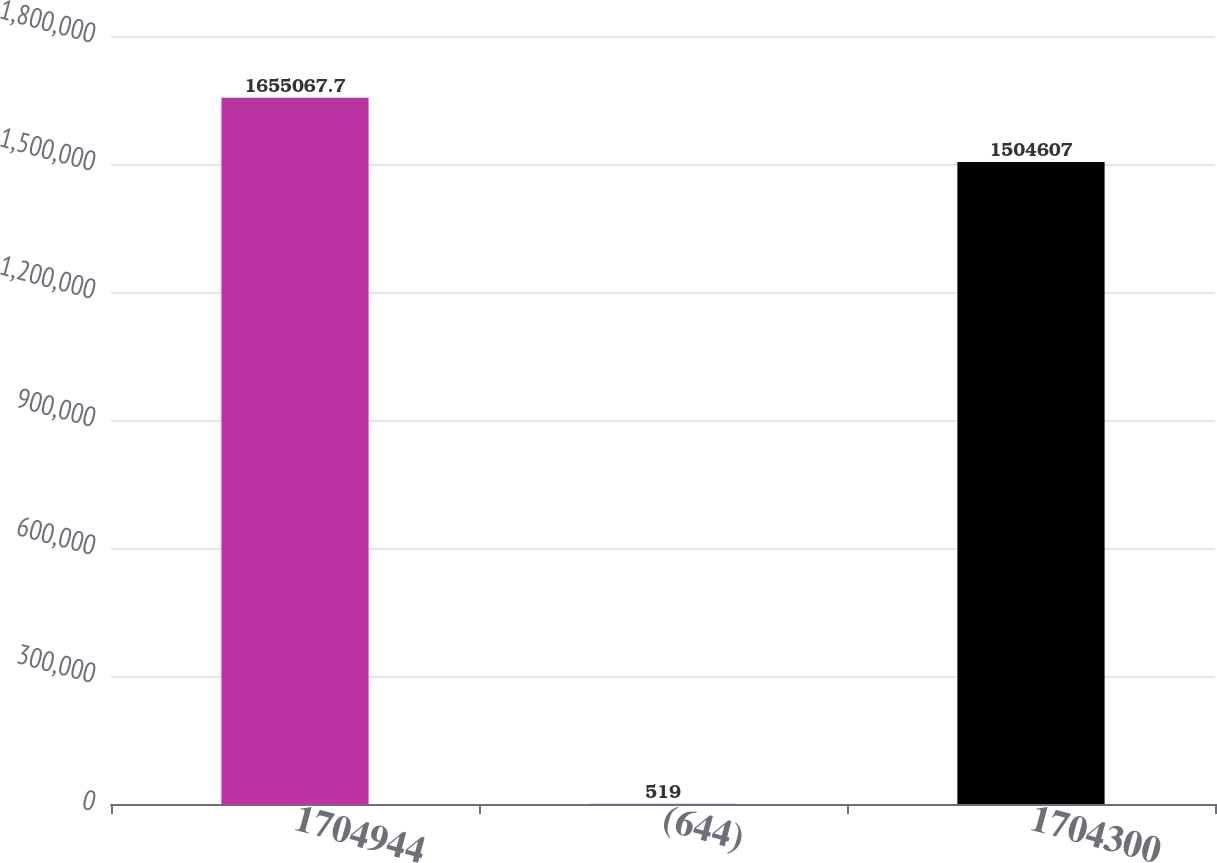Convert chart to OTSL. <chart><loc_0><loc_0><loc_500><loc_500><bar_chart><fcel>1704944<fcel>(644)<fcel>1704300<nl><fcel>1.65507e+06<fcel>519<fcel>1.50461e+06<nl></chart> 